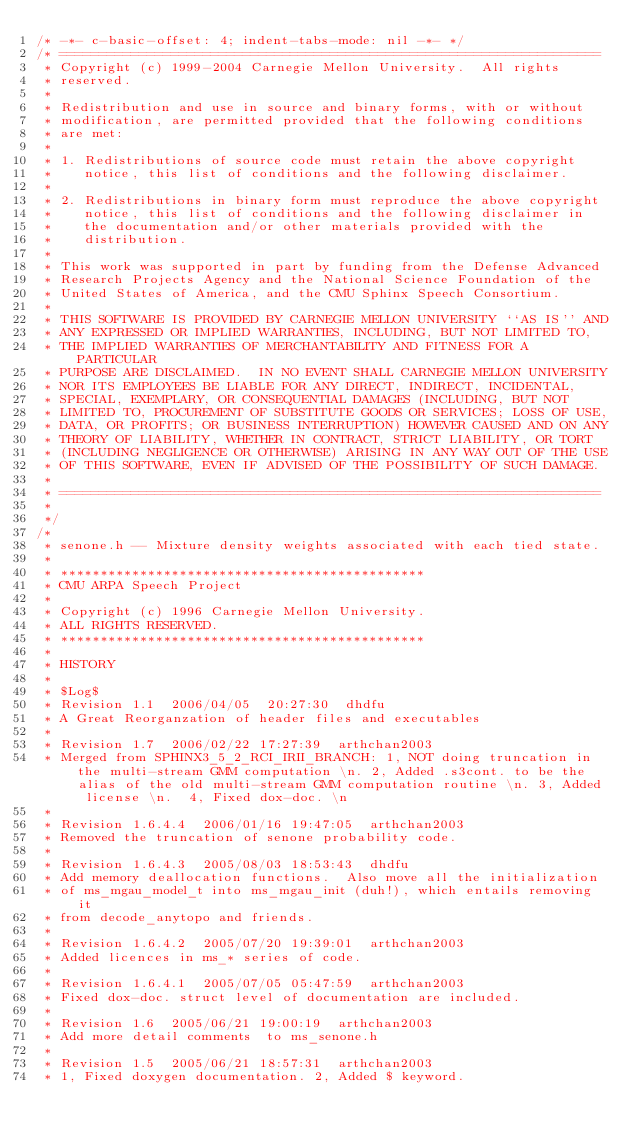Convert code to text. <code><loc_0><loc_0><loc_500><loc_500><_C_>/* -*- c-basic-offset: 4; indent-tabs-mode: nil -*- */
/* ====================================================================
 * Copyright (c) 1999-2004 Carnegie Mellon University.  All rights
 * reserved.
 *
 * Redistribution and use in source and binary forms, with or without
 * modification, are permitted provided that the following conditions
 * are met:
 *
 * 1. Redistributions of source code must retain the above copyright
 *    notice, this list of conditions and the following disclaimer. 
 *
 * 2. Redistributions in binary form must reproduce the above copyright
 *    notice, this list of conditions and the following disclaimer in
 *    the documentation and/or other materials provided with the
 *    distribution.
 *
 * This work was supported in part by funding from the Defense Advanced 
 * Research Projects Agency and the National Science Foundation of the 
 * United States of America, and the CMU Sphinx Speech Consortium.
 *
 * THIS SOFTWARE IS PROVIDED BY CARNEGIE MELLON UNIVERSITY ``AS IS'' AND 
 * ANY EXPRESSED OR IMPLIED WARRANTIES, INCLUDING, BUT NOT LIMITED TO, 
 * THE IMPLIED WARRANTIES OF MERCHANTABILITY AND FITNESS FOR A PARTICULAR
 * PURPOSE ARE DISCLAIMED.  IN NO EVENT SHALL CARNEGIE MELLON UNIVERSITY
 * NOR ITS EMPLOYEES BE LIABLE FOR ANY DIRECT, INDIRECT, INCIDENTAL,
 * SPECIAL, EXEMPLARY, OR CONSEQUENTIAL DAMAGES (INCLUDING, BUT NOT 
 * LIMITED TO, PROCUREMENT OF SUBSTITUTE GOODS OR SERVICES; LOSS OF USE, 
 * DATA, OR PROFITS; OR BUSINESS INTERRUPTION) HOWEVER CAUSED AND ON ANY 
 * THEORY OF LIABILITY, WHETHER IN CONTRACT, STRICT LIABILITY, OR TORT 
 * (INCLUDING NEGLIGENCE OR OTHERWISE) ARISING IN ANY WAY OUT OF THE USE 
 * OF THIS SOFTWARE, EVEN IF ADVISED OF THE POSSIBILITY OF SUCH DAMAGE.
 *
 * ====================================================================
 *
 */
/*
 * senone.h -- Mixture density weights associated with each tied state.
 *
 * **********************************************
 * CMU ARPA Speech Project
 *
 * Copyright (c) 1996 Carnegie Mellon University.
 * ALL RIGHTS RESERVED.
 * **********************************************
 * 
 * HISTORY
 * 
 * $Log$
 * Revision 1.1  2006/04/05  20:27:30  dhdfu
 * A Great Reorganzation of header files and executables
 * 
 * Revision 1.7  2006/02/22 17:27:39  arthchan2003
 * Merged from SPHINX3_5_2_RCI_IRII_BRANCH: 1, NOT doing truncation in the multi-stream GMM computation \n. 2, Added .s3cont. to be the alias of the old multi-stream GMM computation routine \n. 3, Added license \n.  4, Fixed dox-doc. \n
 *
 * Revision 1.6.4.4  2006/01/16 19:47:05  arthchan2003
 * Removed the truncation of senone probability code.
 *
 * Revision 1.6.4.3  2005/08/03 18:53:43  dhdfu
 * Add memory deallocation functions.  Also move all the initialization
 * of ms_mgau_model_t into ms_mgau_init (duh!), which entails removing it
 * from decode_anytopo and friends.
 *
 * Revision 1.6.4.2  2005/07/20 19:39:01  arthchan2003
 * Added licences in ms_* series of code.
 *
 * Revision 1.6.4.1  2005/07/05 05:47:59  arthchan2003
 * Fixed dox-doc. struct level of documentation are included.
 *
 * Revision 1.6  2005/06/21 19:00:19  arthchan2003
 * Add more detail comments  to ms_senone.h
 *
 * Revision 1.5  2005/06/21 18:57:31  arthchan2003
 * 1, Fixed doxygen documentation. 2, Added $ keyword.</code> 